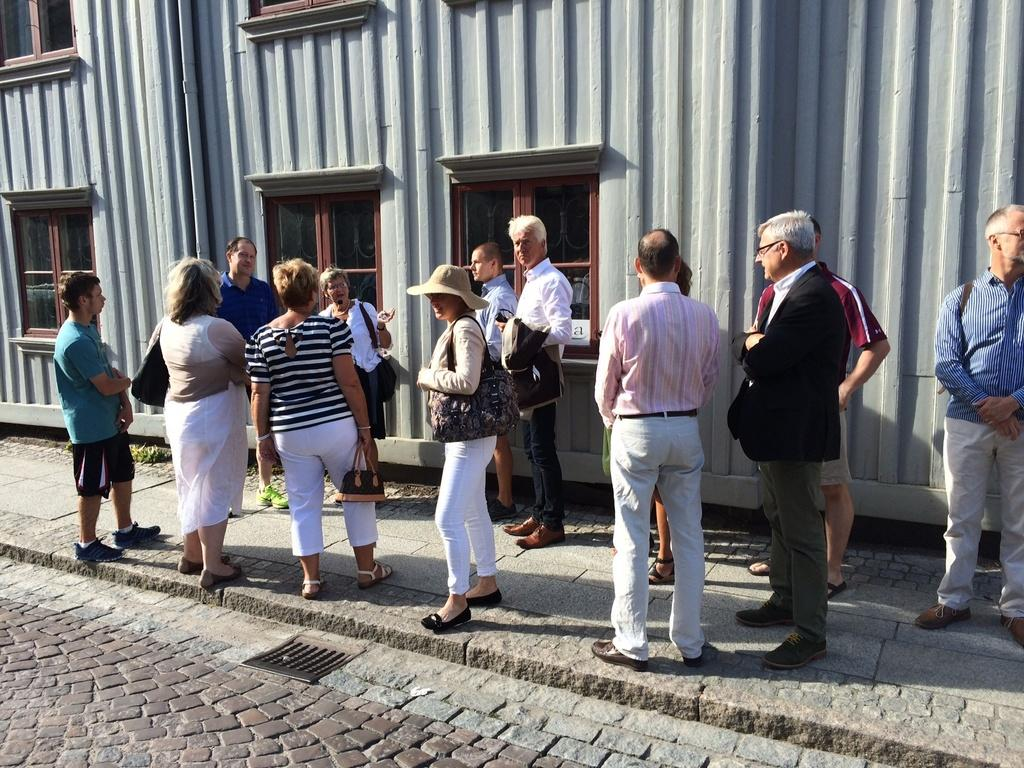What are the persons in the image doing? The persons in the image are standing on the footpath. How are the persons carrying their bags? Some of the persons are carrying bags on their shoulders, while others are carrying bags in their hands. What can be seen in the background of the image? There is a wall in the background of the image, and windows are visible. What type of floor can be seen in the image? There is no floor visible in the image; it only shows persons standing on a footpath and a background with a wall and windows. 